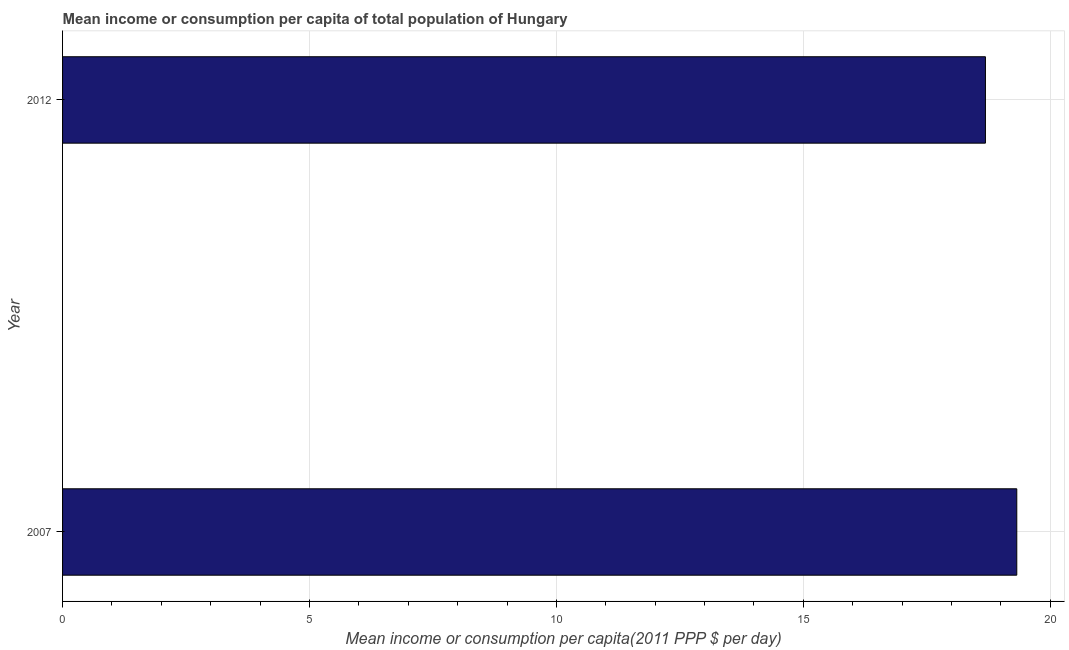Does the graph contain any zero values?
Your answer should be very brief. No. What is the title of the graph?
Offer a very short reply. Mean income or consumption per capita of total population of Hungary. What is the label or title of the X-axis?
Keep it short and to the point. Mean income or consumption per capita(2011 PPP $ per day). What is the mean income or consumption in 2012?
Provide a short and direct response. 18.69. Across all years, what is the maximum mean income or consumption?
Give a very brief answer. 19.32. Across all years, what is the minimum mean income or consumption?
Your answer should be very brief. 18.69. In which year was the mean income or consumption maximum?
Offer a very short reply. 2007. In which year was the mean income or consumption minimum?
Keep it short and to the point. 2012. What is the sum of the mean income or consumption?
Make the answer very short. 38.01. What is the difference between the mean income or consumption in 2007 and 2012?
Your answer should be compact. 0.64. What is the average mean income or consumption per year?
Provide a short and direct response. 19. What is the median mean income or consumption?
Keep it short and to the point. 19.01. What is the ratio of the mean income or consumption in 2007 to that in 2012?
Your answer should be compact. 1.03. Is the mean income or consumption in 2007 less than that in 2012?
Ensure brevity in your answer.  No. In how many years, is the mean income or consumption greater than the average mean income or consumption taken over all years?
Keep it short and to the point. 1. How many bars are there?
Give a very brief answer. 2. Are all the bars in the graph horizontal?
Keep it short and to the point. Yes. How many years are there in the graph?
Your response must be concise. 2. What is the difference between two consecutive major ticks on the X-axis?
Keep it short and to the point. 5. Are the values on the major ticks of X-axis written in scientific E-notation?
Your answer should be compact. No. What is the Mean income or consumption per capita(2011 PPP $ per day) in 2007?
Ensure brevity in your answer.  19.32. What is the Mean income or consumption per capita(2011 PPP $ per day) in 2012?
Your answer should be very brief. 18.69. What is the difference between the Mean income or consumption per capita(2011 PPP $ per day) in 2007 and 2012?
Give a very brief answer. 0.63. What is the ratio of the Mean income or consumption per capita(2011 PPP $ per day) in 2007 to that in 2012?
Make the answer very short. 1.03. 